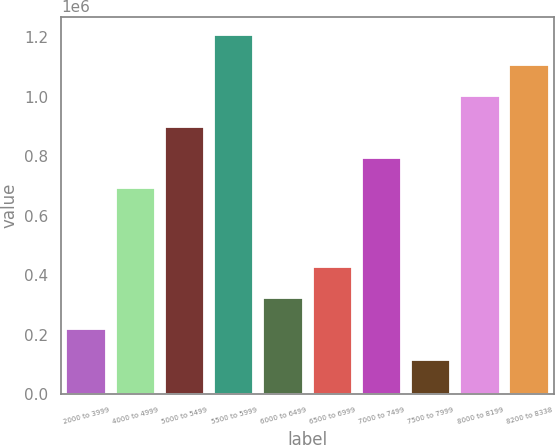<chart> <loc_0><loc_0><loc_500><loc_500><bar_chart><fcel>2000 to 3999<fcel>4000 to 4999<fcel>5000 to 5499<fcel>5500 to 5999<fcel>6000 to 6499<fcel>6500 to 6999<fcel>7000 to 7499<fcel>7500 to 7999<fcel>8000 to 8199<fcel>8200 to 8338<nl><fcel>219510<fcel>692261<fcel>899028<fcel>1.20918e+06<fcel>322893<fcel>426276<fcel>795644<fcel>116126<fcel>1.00241e+06<fcel>1.1058e+06<nl></chart> 